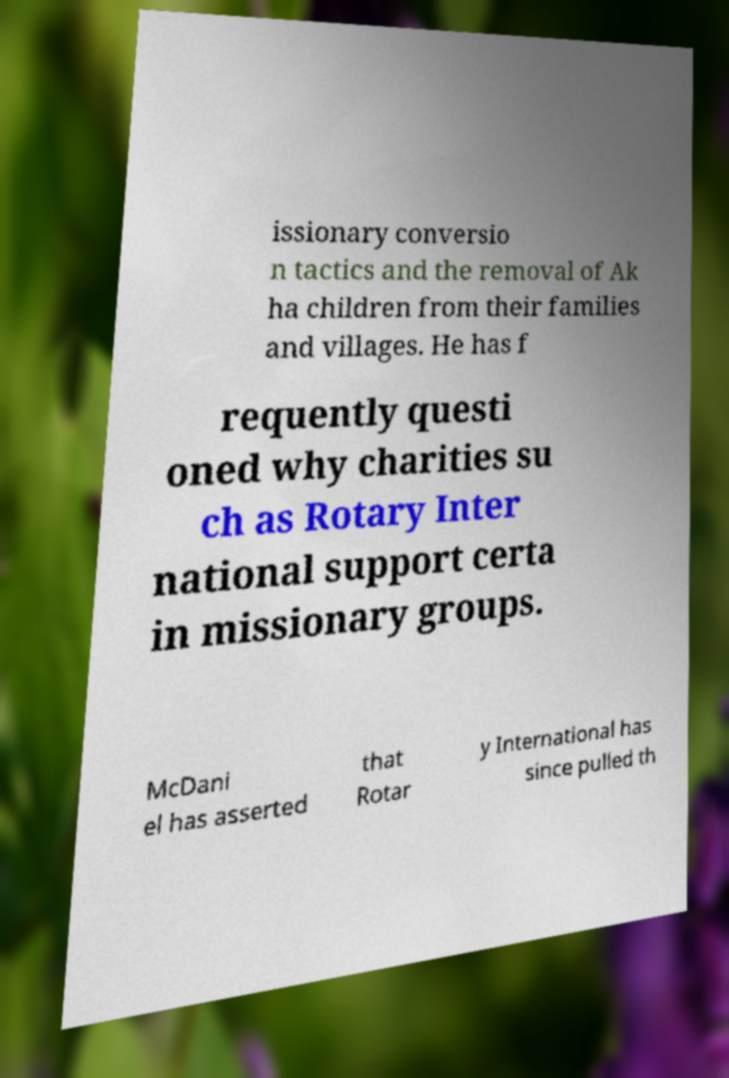Can you read and provide the text displayed in the image?This photo seems to have some interesting text. Can you extract and type it out for me? issionary conversio n tactics and the removal of Ak ha children from their families and villages. He has f requently questi oned why charities su ch as Rotary Inter national support certa in missionary groups. McDani el has asserted that Rotar y International has since pulled th 